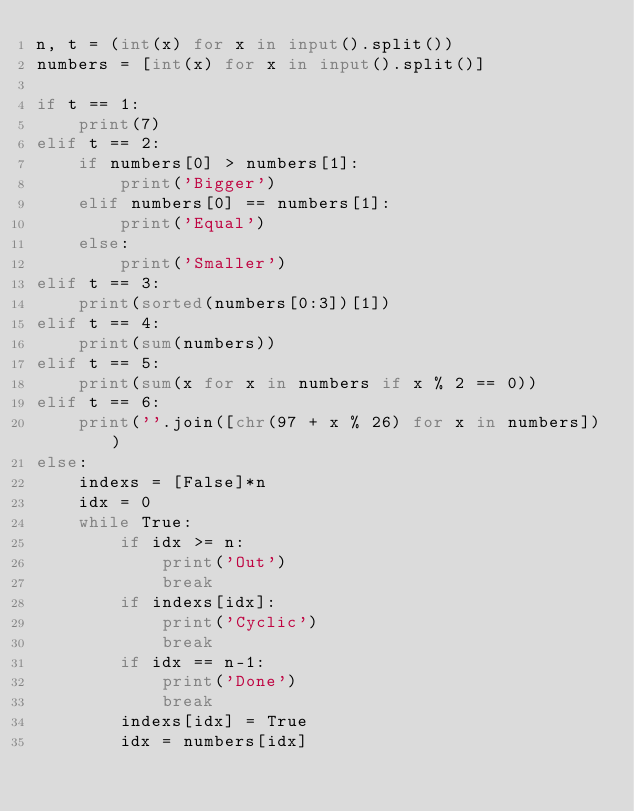Convert code to text. <code><loc_0><loc_0><loc_500><loc_500><_Python_>n, t = (int(x) for x in input().split())
numbers = [int(x) for x in input().split()]

if t == 1:
    print(7)
elif t == 2:
    if numbers[0] > numbers[1]:
        print('Bigger')
    elif numbers[0] == numbers[1]:
        print('Equal')
    else:
        print('Smaller')
elif t == 3:
    print(sorted(numbers[0:3])[1])
elif t == 4:
    print(sum(numbers))
elif t == 5:
    print(sum(x for x in numbers if x % 2 == 0))
elif t == 6:
    print(''.join([chr(97 + x % 26) for x in numbers]))
else:
    indexs = [False]*n
    idx = 0
    while True:
        if idx >= n:
            print('Out')
            break
        if indexs[idx]:
            print('Cyclic')
            break
        if idx == n-1:
            print('Done')
            break
        indexs[idx] = True
        idx = numbers[idx]
</code> 